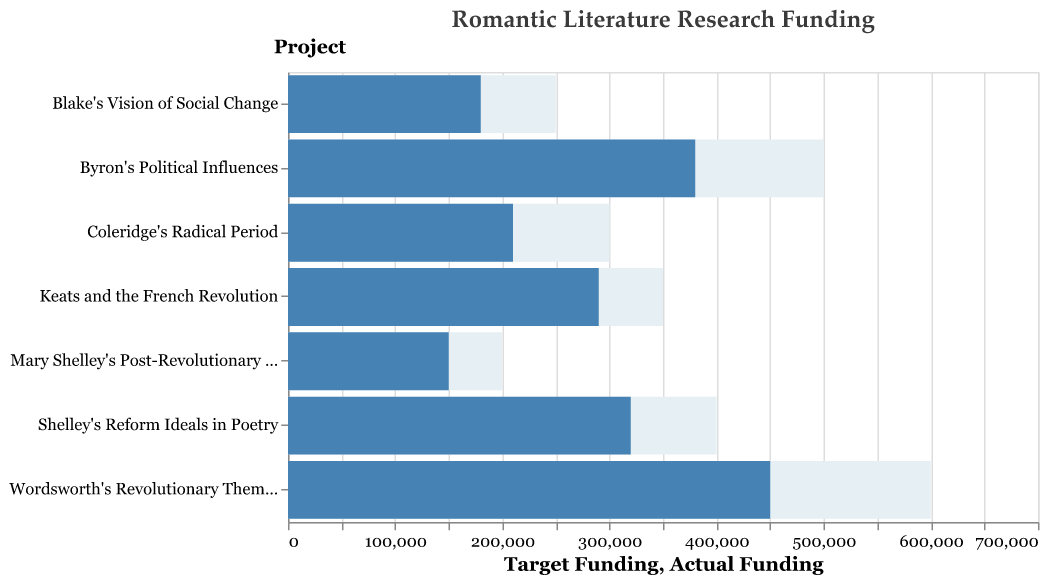What is the title of the figure? The title of the figure is located at the top, specifying the theme of the chart.
Answer: Romantic Literature Research Funding Which project received the highest actual funding? By observing the length of the blue bars representing actual funding, identify the longest bar.
Answer: Wordsworth's Revolutionary Themes How much less actual funding did Blake's Vision of Social Change receive compared to Shelley's Reform Ideals in Poetry? Subtract Blake's actual funding (180,000) from Shelley's actual funding (320,000) to find the difference.
Answer: 140,000 Which project achieved its target funding goal the closest? Calculate the difference between actual funding and target funding for each project and identify the smallest difference.
Answer: Keats and the French Revolution What is the total target funding for all projects combined? Sum the target funding amounts for all projects: 600,000 + 500,000 + 400,000 + 350,000 + 300,000 + 250,000 + 200,000.
Answer: 2,600,000 How many projects have actual funding above 300,000? Count the number of projects with an actual funding value greater than 300,000.
Answer: 2 Which project has the biggest gap between actual and target funding? Identify the project with the largest difference between actual and target funding by calculating the gap for each project.
Answer: Wordsworth's Revolutionary Themes How much actual funding is allocated to Keats and the French Revolution? Look at the blue bar labeled "Keats and the French Revolution" to find the actual funding value.
Answer: 290,000 Is there any project where the actual funding exceeds the target funding? Compare the lengths of all blue bars (actual funding) with their corresponding grey bars (target funding).
Answer: No Which project has the least actual funding? Find the project with the shortest blue bar.
Answer: Mary Shelley's Post-Revolutionary Gothic 